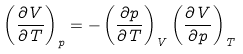<formula> <loc_0><loc_0><loc_500><loc_500>\left ( \frac { \partial V } { \partial T } \right ) _ { p } = - \left ( \frac { \partial p } { \partial T } \right ) _ { V } \left ( \frac { \partial V } { \partial p } \right ) _ { T }</formula> 